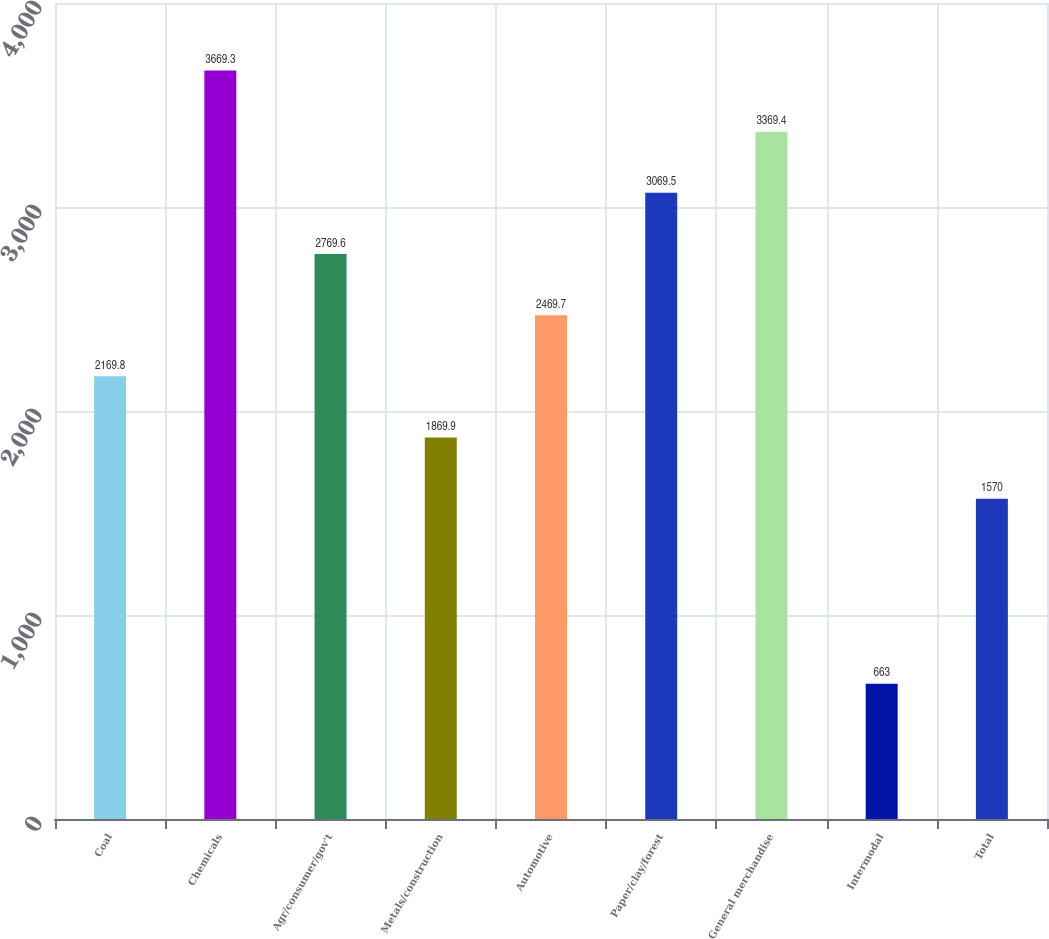<chart> <loc_0><loc_0><loc_500><loc_500><bar_chart><fcel>Coal<fcel>Chemicals<fcel>Agr/consumer/gov't<fcel>Metals/construction<fcel>Automotive<fcel>Paper/clay/forest<fcel>General merchandise<fcel>Intermodal<fcel>Total<nl><fcel>2169.8<fcel>3669.3<fcel>2769.6<fcel>1869.9<fcel>2469.7<fcel>3069.5<fcel>3369.4<fcel>663<fcel>1570<nl></chart> 